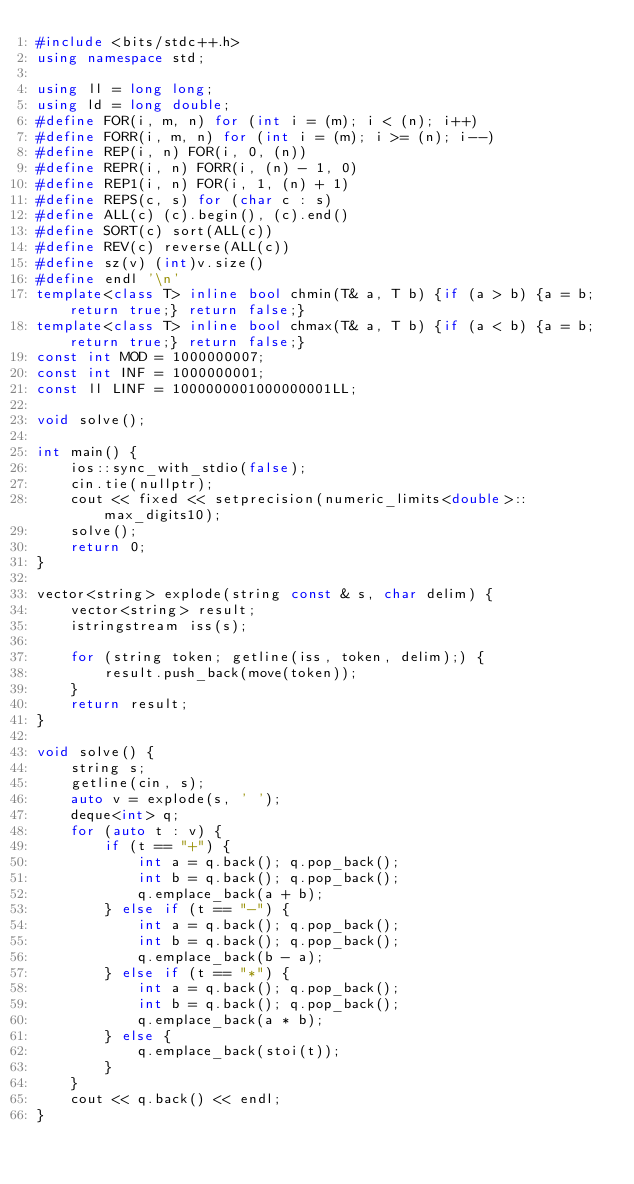<code> <loc_0><loc_0><loc_500><loc_500><_C++_>#include <bits/stdc++.h>
using namespace std;
 
using ll = long long;
using ld = long double;
#define FOR(i, m, n) for (int i = (m); i < (n); i++)
#define FORR(i, m, n) for (int i = (m); i >= (n); i--)
#define REP(i, n) FOR(i, 0, (n))
#define REPR(i, n) FORR(i, (n) - 1, 0)
#define REP1(i, n) FOR(i, 1, (n) + 1)
#define REPS(c, s) for (char c : s)
#define ALL(c) (c).begin(), (c).end()
#define SORT(c) sort(ALL(c))
#define REV(c) reverse(ALL(c))
#define sz(v) (int)v.size()
#define endl '\n'
template<class T> inline bool chmin(T& a, T b) {if (a > b) {a = b; return true;} return false;}
template<class T> inline bool chmax(T& a, T b) {if (a < b) {a = b; return true;} return false;}
const int MOD = 1000000007;
const int INF = 1000000001;
const ll LINF = 1000000001000000001LL;
 
void solve();
 
int main() {
    ios::sync_with_stdio(false);
    cin.tie(nullptr);
    cout << fixed << setprecision(numeric_limits<double>::max_digits10);
    solve();
    return 0;
}

vector<string> explode(string const & s, char delim) {
    vector<string> result;
    istringstream iss(s);

    for (string token; getline(iss, token, delim);) {
        result.push_back(move(token));
    }
    return result;
}

void solve() {
    string s;
    getline(cin, s);
    auto v = explode(s, ' ');
    deque<int> q;
    for (auto t : v) {
        if (t == "+") {
            int a = q.back(); q.pop_back();
            int b = q.back(); q.pop_back();
            q.emplace_back(a + b);
        } else if (t == "-") {
            int a = q.back(); q.pop_back();
            int b = q.back(); q.pop_back();
            q.emplace_back(b - a);
        } else if (t == "*") {
            int a = q.back(); q.pop_back();
            int b = q.back(); q.pop_back();
            q.emplace_back(a * b);
        } else {
            q.emplace_back(stoi(t));
        }
    }
    cout << q.back() << endl;
}

</code> 